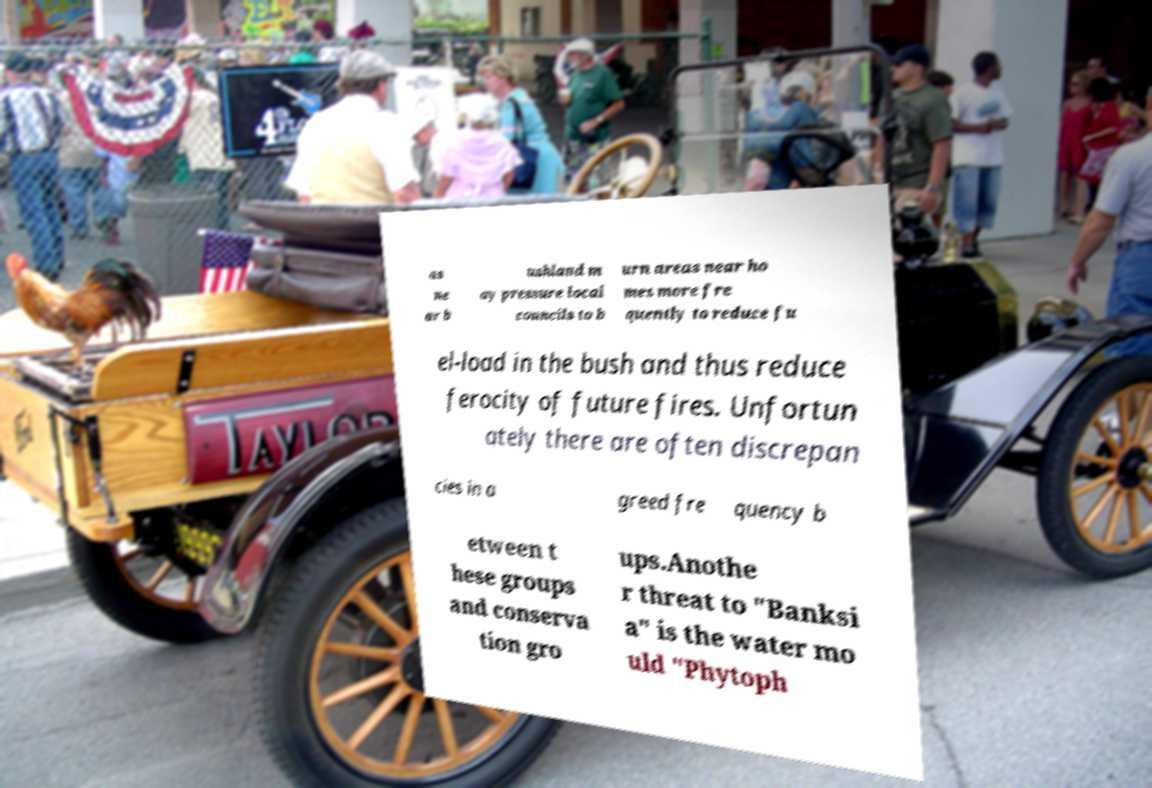Could you extract and type out the text from this image? as ne ar b ushland m ay pressure local councils to b urn areas near ho mes more fre quently to reduce fu el-load in the bush and thus reduce ferocity of future fires. Unfortun ately there are often discrepan cies in a greed fre quency b etween t hese groups and conserva tion gro ups.Anothe r threat to "Banksi a" is the water mo uld "Phytoph 